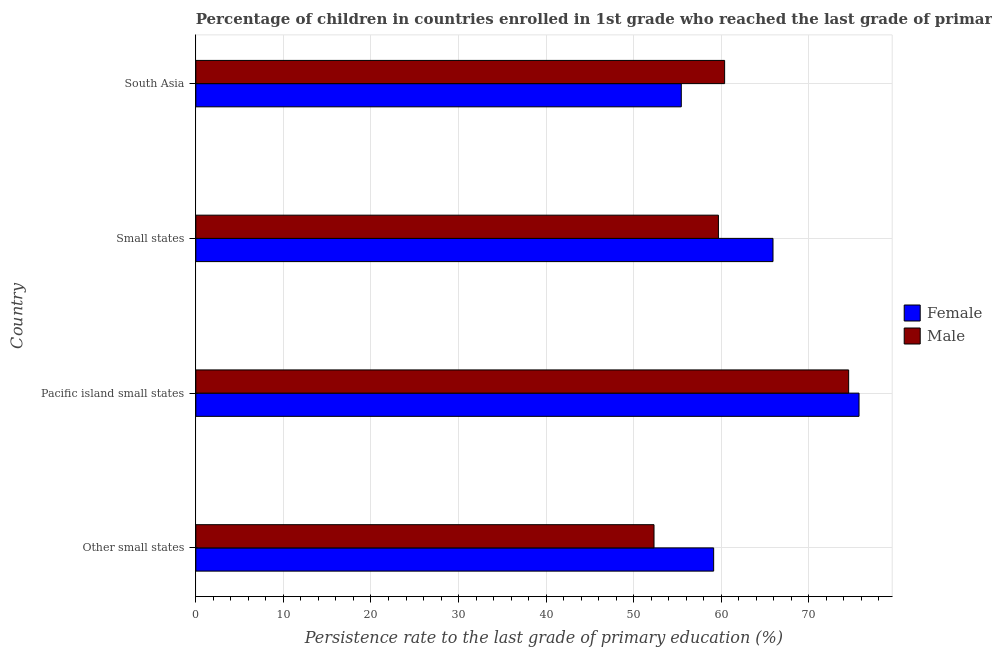How many different coloured bars are there?
Your answer should be compact. 2. How many bars are there on the 1st tick from the top?
Provide a short and direct response. 2. What is the label of the 2nd group of bars from the top?
Provide a short and direct response. Small states. What is the persistence rate of female students in South Asia?
Offer a terse response. 55.43. Across all countries, what is the maximum persistence rate of male students?
Provide a short and direct response. 74.54. Across all countries, what is the minimum persistence rate of female students?
Your response must be concise. 55.43. In which country was the persistence rate of male students maximum?
Offer a terse response. Pacific island small states. What is the total persistence rate of male students in the graph?
Offer a terse response. 246.92. What is the difference between the persistence rate of female students in Other small states and that in Pacific island small states?
Provide a short and direct response. -16.6. What is the difference between the persistence rate of male students in Pacific island small states and the persistence rate of female students in Small states?
Offer a terse response. 8.64. What is the average persistence rate of male students per country?
Offer a very short reply. 61.73. What is the difference between the persistence rate of male students and persistence rate of female students in South Asia?
Keep it short and to the point. 4.95. In how many countries, is the persistence rate of female students greater than 36 %?
Make the answer very short. 4. What is the ratio of the persistence rate of male students in Other small states to that in Small states?
Your answer should be very brief. 0.88. Is the difference between the persistence rate of female students in Pacific island small states and Small states greater than the difference between the persistence rate of male students in Pacific island small states and Small states?
Make the answer very short. No. What is the difference between the highest and the second highest persistence rate of female students?
Give a very brief answer. 9.82. What is the difference between the highest and the lowest persistence rate of male students?
Provide a succinct answer. 22.23. In how many countries, is the persistence rate of male students greater than the average persistence rate of male students taken over all countries?
Provide a short and direct response. 1. What is the difference between two consecutive major ticks on the X-axis?
Keep it short and to the point. 10. Does the graph contain any zero values?
Give a very brief answer. No. How are the legend labels stacked?
Offer a very short reply. Vertical. What is the title of the graph?
Ensure brevity in your answer.  Percentage of children in countries enrolled in 1st grade who reached the last grade of primary education. What is the label or title of the X-axis?
Offer a very short reply. Persistence rate to the last grade of primary education (%). What is the label or title of the Y-axis?
Offer a very short reply. Country. What is the Persistence rate to the last grade of primary education (%) of Female in Other small states?
Your response must be concise. 59.13. What is the Persistence rate to the last grade of primary education (%) in Male in Other small states?
Make the answer very short. 52.32. What is the Persistence rate to the last grade of primary education (%) in Female in Pacific island small states?
Your response must be concise. 75.73. What is the Persistence rate to the last grade of primary education (%) in Male in Pacific island small states?
Ensure brevity in your answer.  74.54. What is the Persistence rate to the last grade of primary education (%) in Female in Small states?
Keep it short and to the point. 65.91. What is the Persistence rate to the last grade of primary education (%) in Male in Small states?
Give a very brief answer. 59.67. What is the Persistence rate to the last grade of primary education (%) of Female in South Asia?
Offer a very short reply. 55.43. What is the Persistence rate to the last grade of primary education (%) of Male in South Asia?
Your answer should be very brief. 60.38. Across all countries, what is the maximum Persistence rate to the last grade of primary education (%) in Female?
Make the answer very short. 75.73. Across all countries, what is the maximum Persistence rate to the last grade of primary education (%) of Male?
Your response must be concise. 74.54. Across all countries, what is the minimum Persistence rate to the last grade of primary education (%) of Female?
Provide a short and direct response. 55.43. Across all countries, what is the minimum Persistence rate to the last grade of primary education (%) in Male?
Your answer should be compact. 52.32. What is the total Persistence rate to the last grade of primary education (%) in Female in the graph?
Your answer should be very brief. 256.2. What is the total Persistence rate to the last grade of primary education (%) of Male in the graph?
Provide a succinct answer. 246.92. What is the difference between the Persistence rate to the last grade of primary education (%) of Female in Other small states and that in Pacific island small states?
Ensure brevity in your answer.  -16.6. What is the difference between the Persistence rate to the last grade of primary education (%) of Male in Other small states and that in Pacific island small states?
Provide a succinct answer. -22.23. What is the difference between the Persistence rate to the last grade of primary education (%) in Female in Other small states and that in Small states?
Your response must be concise. -6.78. What is the difference between the Persistence rate to the last grade of primary education (%) of Male in Other small states and that in Small states?
Offer a terse response. -7.35. What is the difference between the Persistence rate to the last grade of primary education (%) in Female in Other small states and that in South Asia?
Your response must be concise. 3.7. What is the difference between the Persistence rate to the last grade of primary education (%) of Male in Other small states and that in South Asia?
Give a very brief answer. -8.06. What is the difference between the Persistence rate to the last grade of primary education (%) of Female in Pacific island small states and that in Small states?
Your answer should be compact. 9.82. What is the difference between the Persistence rate to the last grade of primary education (%) in Male in Pacific island small states and that in Small states?
Make the answer very short. 14.87. What is the difference between the Persistence rate to the last grade of primary education (%) of Female in Pacific island small states and that in South Asia?
Give a very brief answer. 20.3. What is the difference between the Persistence rate to the last grade of primary education (%) of Male in Pacific island small states and that in South Asia?
Keep it short and to the point. 14.16. What is the difference between the Persistence rate to the last grade of primary education (%) of Female in Small states and that in South Asia?
Offer a terse response. 10.47. What is the difference between the Persistence rate to the last grade of primary education (%) in Male in Small states and that in South Asia?
Make the answer very short. -0.71. What is the difference between the Persistence rate to the last grade of primary education (%) in Female in Other small states and the Persistence rate to the last grade of primary education (%) in Male in Pacific island small states?
Provide a short and direct response. -15.41. What is the difference between the Persistence rate to the last grade of primary education (%) of Female in Other small states and the Persistence rate to the last grade of primary education (%) of Male in Small states?
Provide a short and direct response. -0.54. What is the difference between the Persistence rate to the last grade of primary education (%) in Female in Other small states and the Persistence rate to the last grade of primary education (%) in Male in South Asia?
Offer a very short reply. -1.25. What is the difference between the Persistence rate to the last grade of primary education (%) in Female in Pacific island small states and the Persistence rate to the last grade of primary education (%) in Male in Small states?
Give a very brief answer. 16.06. What is the difference between the Persistence rate to the last grade of primary education (%) in Female in Pacific island small states and the Persistence rate to the last grade of primary education (%) in Male in South Asia?
Your response must be concise. 15.35. What is the difference between the Persistence rate to the last grade of primary education (%) of Female in Small states and the Persistence rate to the last grade of primary education (%) of Male in South Asia?
Your answer should be very brief. 5.52. What is the average Persistence rate to the last grade of primary education (%) of Female per country?
Your answer should be very brief. 64.05. What is the average Persistence rate to the last grade of primary education (%) in Male per country?
Offer a terse response. 61.73. What is the difference between the Persistence rate to the last grade of primary education (%) in Female and Persistence rate to the last grade of primary education (%) in Male in Other small states?
Your answer should be compact. 6.81. What is the difference between the Persistence rate to the last grade of primary education (%) of Female and Persistence rate to the last grade of primary education (%) of Male in Pacific island small states?
Make the answer very short. 1.18. What is the difference between the Persistence rate to the last grade of primary education (%) in Female and Persistence rate to the last grade of primary education (%) in Male in Small states?
Offer a terse response. 6.23. What is the difference between the Persistence rate to the last grade of primary education (%) in Female and Persistence rate to the last grade of primary education (%) in Male in South Asia?
Your response must be concise. -4.95. What is the ratio of the Persistence rate to the last grade of primary education (%) in Female in Other small states to that in Pacific island small states?
Give a very brief answer. 0.78. What is the ratio of the Persistence rate to the last grade of primary education (%) of Male in Other small states to that in Pacific island small states?
Your response must be concise. 0.7. What is the ratio of the Persistence rate to the last grade of primary education (%) of Female in Other small states to that in Small states?
Your response must be concise. 0.9. What is the ratio of the Persistence rate to the last grade of primary education (%) of Male in Other small states to that in Small states?
Ensure brevity in your answer.  0.88. What is the ratio of the Persistence rate to the last grade of primary education (%) in Female in Other small states to that in South Asia?
Your answer should be compact. 1.07. What is the ratio of the Persistence rate to the last grade of primary education (%) in Male in Other small states to that in South Asia?
Ensure brevity in your answer.  0.87. What is the ratio of the Persistence rate to the last grade of primary education (%) in Female in Pacific island small states to that in Small states?
Your response must be concise. 1.15. What is the ratio of the Persistence rate to the last grade of primary education (%) of Male in Pacific island small states to that in Small states?
Provide a short and direct response. 1.25. What is the ratio of the Persistence rate to the last grade of primary education (%) of Female in Pacific island small states to that in South Asia?
Your answer should be compact. 1.37. What is the ratio of the Persistence rate to the last grade of primary education (%) of Male in Pacific island small states to that in South Asia?
Provide a short and direct response. 1.23. What is the ratio of the Persistence rate to the last grade of primary education (%) in Female in Small states to that in South Asia?
Offer a very short reply. 1.19. What is the ratio of the Persistence rate to the last grade of primary education (%) in Male in Small states to that in South Asia?
Keep it short and to the point. 0.99. What is the difference between the highest and the second highest Persistence rate to the last grade of primary education (%) in Female?
Offer a very short reply. 9.82. What is the difference between the highest and the second highest Persistence rate to the last grade of primary education (%) in Male?
Keep it short and to the point. 14.16. What is the difference between the highest and the lowest Persistence rate to the last grade of primary education (%) in Female?
Your answer should be very brief. 20.3. What is the difference between the highest and the lowest Persistence rate to the last grade of primary education (%) in Male?
Provide a short and direct response. 22.23. 